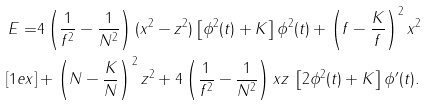Convert formula to latex. <formula><loc_0><loc_0><loc_500><loc_500>E = & 4 \left ( \frac { 1 } { f ^ { 2 } } - \frac { 1 } { N ^ { 2 } } \right ) ( x ^ { 2 } - z ^ { 2 } ) \left [ \phi ^ { 2 } ( t ) + K \right ] \phi ^ { 2 } ( t ) + \left ( f - \frac { K } { f } \right ) ^ { 2 } x ^ { 2 } \\ [ 1 e x ] & + \left ( N - \frac { K } { N } \right ) ^ { 2 } z ^ { 2 } + 4 \left ( \frac { 1 } { f ^ { 2 } } - \frac { 1 } { N ^ { 2 } } \right ) x z \, \left [ 2 \phi ^ { 2 } ( t ) + K \right ] \phi ^ { \prime } ( t ) .</formula> 